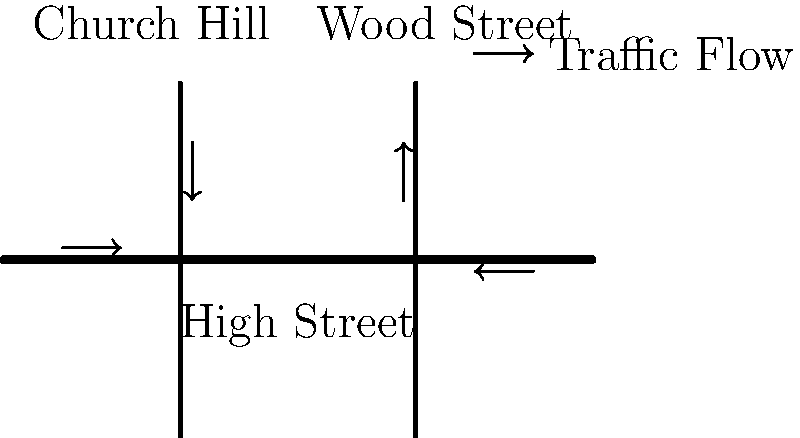Based on the simplified road map of Chipping Barnet's town center, which shows the High Street intersected by Church Hill and Wood Street, what can be inferred about the traffic flow patterns during peak hours? To answer this question, let's analyze the traffic flow patterns shown in the diagram:

1. High Street:
   - There's an arrow pointing east (right) on the western side of High Street.
   - There's an arrow pointing west (left) on the eastern side of High Street.
   - This indicates that High Street is likely a two-way road with traffic flowing in both directions.

2. Church Hill (left intersection):
   - There's an arrow pointing south (down) on Church Hill.
   - This suggests that during peak hours, there's significant traffic flowing from Church Hill onto High Street.

3. Wood Street (right intersection):
   - There's an arrow pointing north (up) on Wood Street.
   - This indicates that during peak hours, there's significant traffic flowing from High Street onto Wood Street.

4. Overall pattern:
   - The arrows suggest a clockwise traffic flow around the town center.
   - Traffic seems to enter the area from the west on High Street and north on Church Hill.
   - Traffic appears to exit the area to the east on High Street and north on Wood Street.

5. Implications:
   - This pattern could indicate that during peak hours, many people are entering the town center for work or shopping, and then leaving via different routes.
   - The clockwise flow might be designed to reduce congestion and improve traffic management.

Given these observations, we can infer that during peak hours, there's a predominant clockwise traffic flow pattern around Chipping Barnet's town center, with traffic entering via western High Street and Church Hill, and exiting via eastern High Street and Wood Street.
Answer: Clockwise traffic flow pattern around the town center during peak hours. 